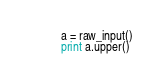<code> <loc_0><loc_0><loc_500><loc_500><_Python_>a = raw_input()
print a.upper()</code> 